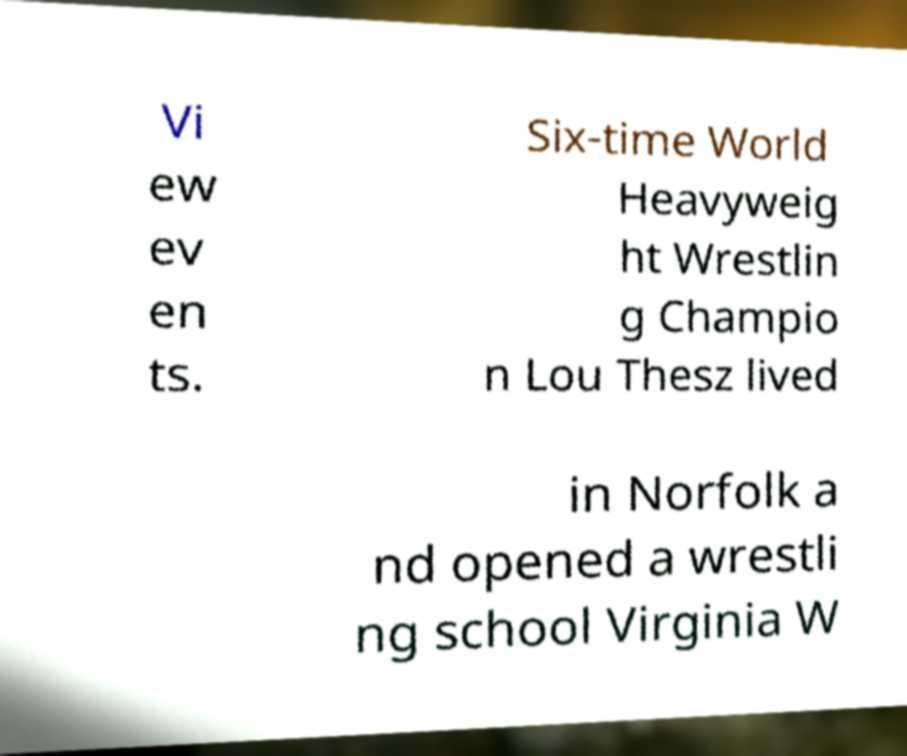Could you extract and type out the text from this image? Vi ew ev en ts. Six-time World Heavyweig ht Wrestlin g Champio n Lou Thesz lived in Norfolk a nd opened a wrestli ng school Virginia W 